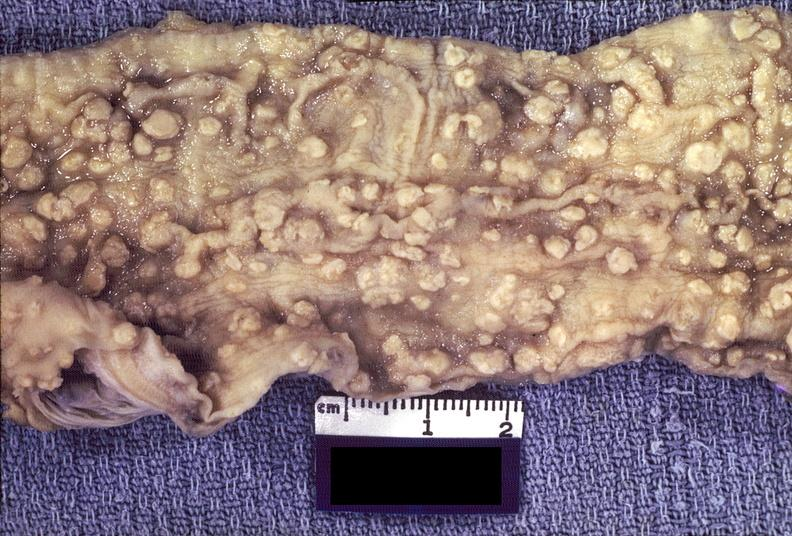s fibrinous peritonitis present?
Answer the question using a single word or phrase. No 